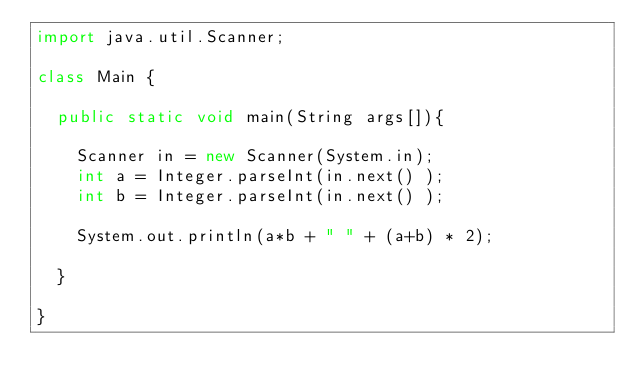<code> <loc_0><loc_0><loc_500><loc_500><_Java_>import java.util.Scanner;

class Main {

	public static void main(String args[]){

		Scanner in = new Scanner(System.in);
		int a = Integer.parseInt(in.next() );
		int b = Integer.parseInt(in.next() );

		System.out.println(a*b + " " + (a+b) * 2);

	}

}</code> 